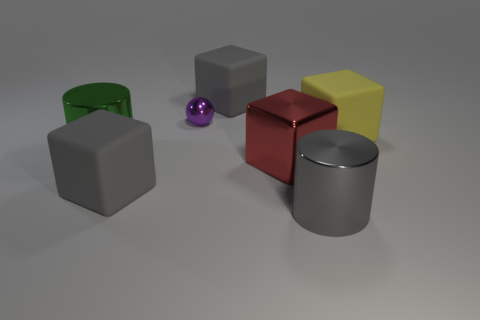Is there any other thing that has the same size as the purple ball?
Offer a very short reply. No. Does the tiny purple object have the same material as the large cylinder right of the metal cube?
Offer a very short reply. Yes. The red block that is made of the same material as the purple ball is what size?
Provide a short and direct response. Large. Is the number of large cylinders that are left of the purple shiny ball greater than the number of big yellow objects to the left of the big yellow matte block?
Ensure brevity in your answer.  Yes. Is there a small blue rubber object that has the same shape as the large gray metal thing?
Your response must be concise. No. There is a metal object that is in front of the red shiny thing; is it the same size as the big green metal thing?
Your answer should be very brief. Yes. Are any brown metallic balls visible?
Offer a terse response. No. What number of things are matte cubes that are on the right side of the gray shiny thing or shiny balls?
Provide a succinct answer. 2. Are there any gray blocks that have the same size as the red cube?
Your response must be concise. Yes. There is a large gray thing right of the gray rubber thing behind the large green metal thing; what is its material?
Your answer should be very brief. Metal. 